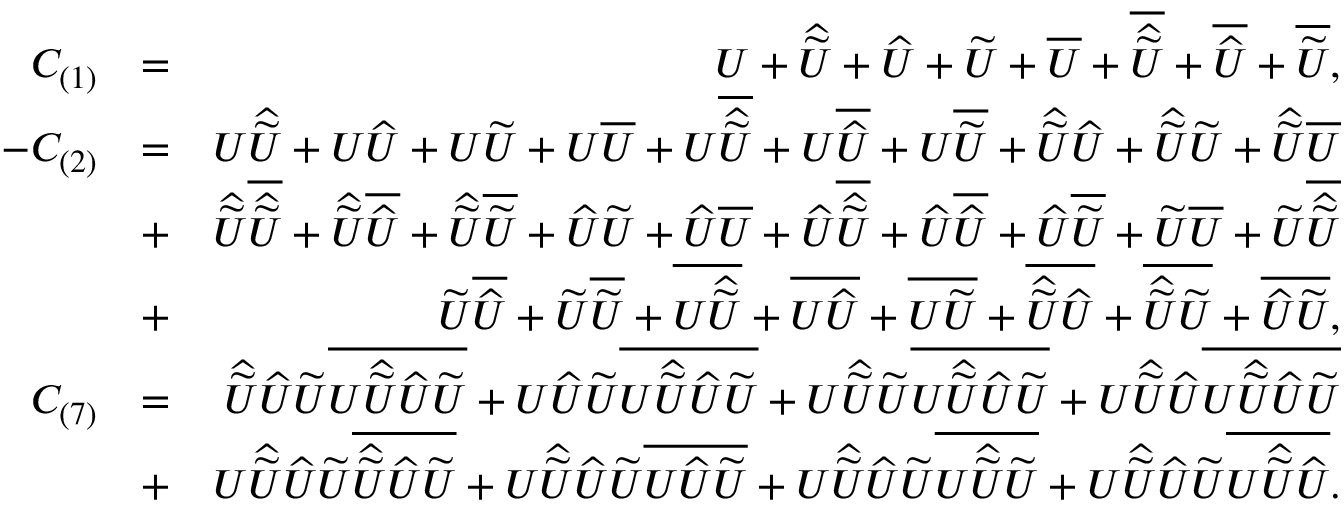<formula> <loc_0><loc_0><loc_500><loc_500>\begin{array} { r l r } { C _ { ( 1 ) } } & { = } & { U + \widehat { \widetilde { U } } + \widehat { U } + \widetilde { U } + \overline { U } + \overline { { \widehat { \widetilde { U } } } } + \overline { { \widehat { U } } } + \overline { { \widetilde { U } } } , } \\ { - C _ { ( 2 ) } } & { = } & { U \widehat { \widetilde { U } } + U \widehat { U } + U \widetilde { U } + U \overline { U } + U \overline { { \widehat { \widetilde { U } } } } + U \overline { { \widehat { U } } } + U \overline { { \widetilde { U } } } + \widehat { \widetilde { U } } \widehat { U } + \widehat { \widetilde { U } } \widetilde { U } + \widehat { \widetilde { U } } \overline { U } } \\ & { + } & { \widehat { \widetilde { U } } \overline { { \widehat { \widetilde { U } } } } + \widehat { \widetilde { U } } \overline { { \widehat { U } } } + \widehat { \widetilde { U } } \overline { { \widetilde { U } } } + \widehat { U } \widetilde { U } + \widehat { U } \overline { U } + \widehat { U } \overline { { \widehat { \widetilde { U } } } } + \widehat { U } \overline { { \widehat { U } } } + \widehat { U } \overline { { \widetilde { U } } } + \widetilde { U } \overline { U } + \widetilde { U } \overline { { \widehat { \widetilde { U } } } } } \\ & { + } & { \widetilde { U } \overline { { \widehat { U } } } + \widetilde { U } \overline { { \widetilde { U } } } + \overline { { U \widehat { \widetilde { U } } } } + \overline { { U \widehat { U } } } + \overline { { U \widetilde { U } } } + \overline { { \widehat { \widetilde { U } } \widehat { U } } } + \overline { { \widehat { \widetilde { U } } \widetilde { U } } } + \overline { { \widehat { U } \widetilde { U } } } , } \\ { C _ { ( 7 ) } } & { = } & { \widehat { \widetilde { U } } \widehat { U } \widetilde { U } \overline { { U \widehat { \widetilde { U } } \widehat { U } \widetilde { U } } } + U \widehat { U } \widetilde { U } \overline { { U \widehat { \widetilde { U } } \widehat { U } \widetilde { U } } } + U \widehat { \widetilde { U } } \widetilde { U } \overline { { U \widehat { \widetilde { U } } \widehat { U } \widetilde { U } } } + U \widehat { \widetilde { U } } \widehat { U } \overline { { U \widehat { \widetilde { U } } \widehat { U } \widetilde { U } } } } \\ & { + } & { U \widehat { \widetilde { U } } \widehat { U } \widetilde { U } \overline { { \widehat { \widetilde { U } } \widehat { U } \widetilde { U } } } + U \widehat { \widetilde { U } } \widehat { U } \widetilde { U } \overline { { U \widehat { U } \widetilde { U } } } + U \widehat { \widetilde { U } } \widehat { U } \widetilde { U } \overline { { U \widehat { \widetilde { U } } \widetilde { U } } } + U \widehat { \widetilde { U } } \widehat { U } \widetilde { U } \overline { { U \widehat { \widetilde { U } } \widehat { U } } } . } \end{array}</formula> 